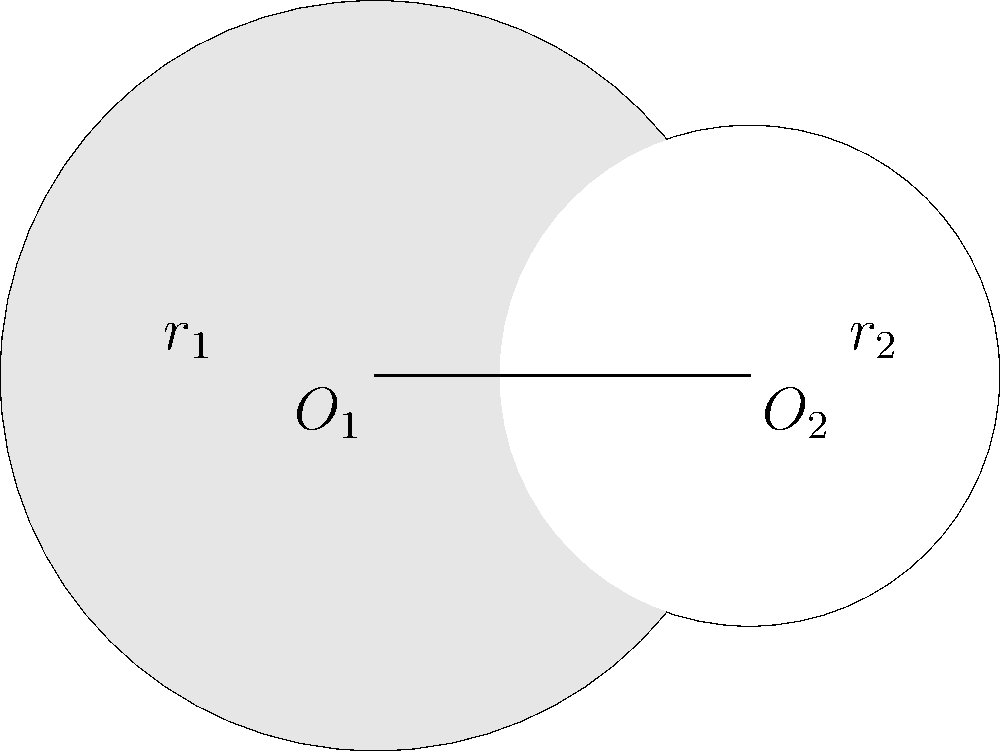In the diagram, two circles with centers $O_1$ and $O_2$ intersect. The radius of the larger circle ($O_1$) is $r_1 = 1.5$ units, and the radius of the smaller circle ($O_2$) is $r_2 = 1$ unit. The distance between the centers is 1.5 units. Calculate the area of the shaded region formed by the intersection of these circles. To find the area of the shaded region, we'll follow these steps:

1) First, we need to find the central angle $\theta$ of the sector in the larger circle:
   $\cos(\theta/2) = \frac{1.5^2 + 1.5^2 - 1^2}{2 \cdot 1.5 \cdot 1.5} = \frac{3.5}{4.5}$
   $\theta = 2 \arccos(\frac{3.5}{4.5}) \approx 1.8395$ radians

2) The area of the sector in the larger circle is:
   $A_1 = \frac{1}{2} \cdot 1.5^2 \cdot 1.8395 \approx 2.0694$ square units

3) The area of the triangle formed by $O_1$, $O_2$, and the intersection point is:
   $A_t = \frac{1}{2} \cdot 1.5 \cdot 1 \cdot \sin(1.8395) \approx 0.7211$ square units

4) The area of the segment in the larger circle is:
   $A_{s1} = A_1 - A_t \approx 1.3483$ square units

5) Now, we need to find the central angle $\phi$ of the sector in the smaller circle:
   $\cos(\phi/2) = \frac{1^2 + 1.5^2 - 1.5^2}{2 \cdot 1 \cdot 1.5} = \frac{1}{3}$
   $\phi = 2 \arccos(\frac{1}{3}) \approx 2.5447$ radians

6) The area of the sector in the smaller circle is:
   $A_2 = \frac{1}{2} \cdot 1^2 \cdot 2.5447 \approx 1.2724$ square units

7) The area of the triangle formed by $O_2$, $O_1$, and the intersection point is the same as before:
   $A_t \approx 0.7211$ square units

8) The area of the segment in the smaller circle is:
   $A_{s2} = A_2 - A_t \approx 0.5513$ square units

9) The shaded area is the difference between the area of the segment in the larger circle and the area of the segment in the smaller circle:
   $A_{shaded} = A_{s1} - A_{s2} \approx 1.3483 - 0.5513 \approx 0.7970$ square units
Answer: $0.7970$ square units 